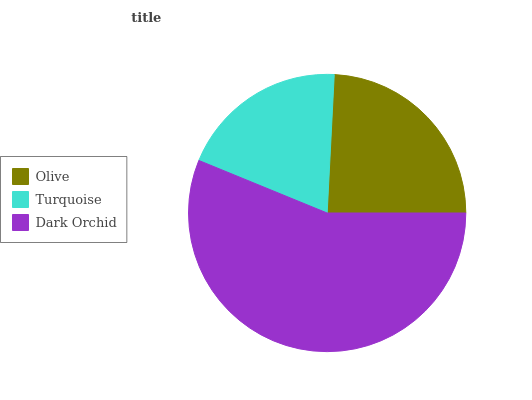Is Turquoise the minimum?
Answer yes or no. Yes. Is Dark Orchid the maximum?
Answer yes or no. Yes. Is Dark Orchid the minimum?
Answer yes or no. No. Is Turquoise the maximum?
Answer yes or no. No. Is Dark Orchid greater than Turquoise?
Answer yes or no. Yes. Is Turquoise less than Dark Orchid?
Answer yes or no. Yes. Is Turquoise greater than Dark Orchid?
Answer yes or no. No. Is Dark Orchid less than Turquoise?
Answer yes or no. No. Is Olive the high median?
Answer yes or no. Yes. Is Olive the low median?
Answer yes or no. Yes. Is Dark Orchid the high median?
Answer yes or no. No. Is Turquoise the low median?
Answer yes or no. No. 